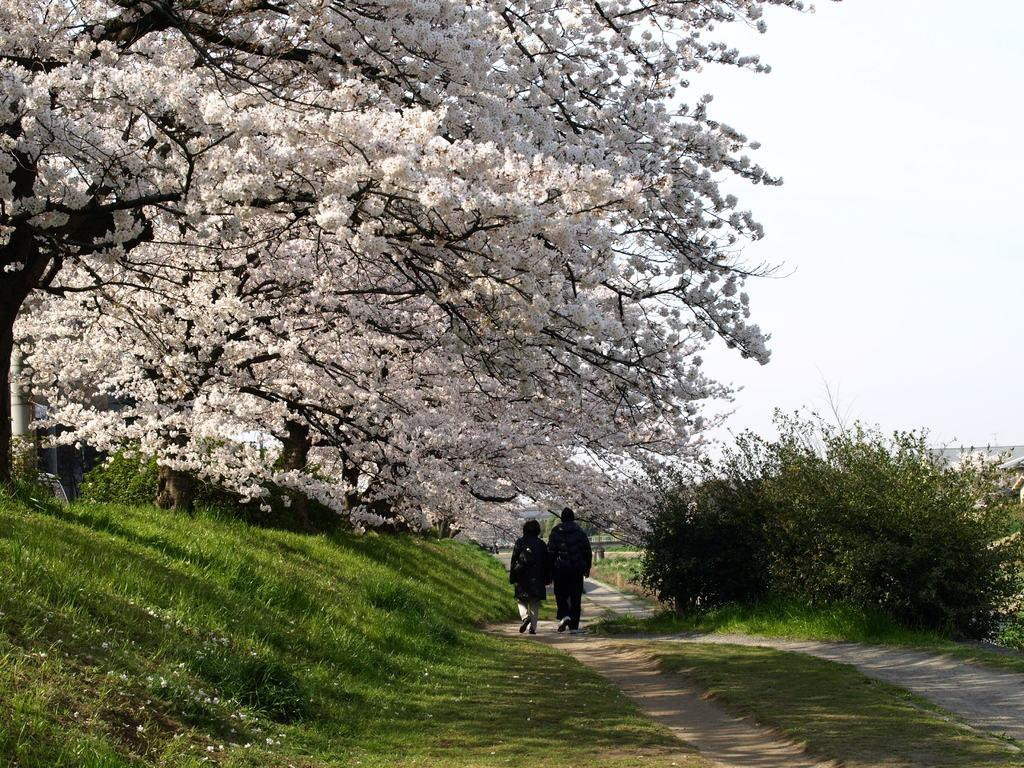How many people are in the image? There are two persons standing in the image. What is the surface they are standing on? The persons are standing on the ground. What type of vegetation can be seen in the image? There is grass visible in the image. What kind of path is present in the image? There is a path in the image. What else can be seen in the image besides the persons and the path? There are trees in the image. What is visible in the background of the image? The sky is visible in the background of the image. What type of frame is used to display the rhythm of the nation in the image? There is no frame, rhythm, or nation mentioned or depicted in the image. 